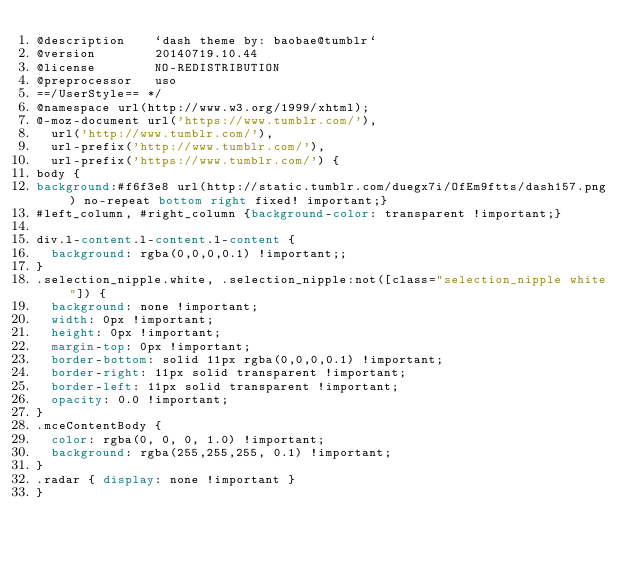<code> <loc_0><loc_0><loc_500><loc_500><_CSS_>@description    `dash theme by: baobae@tumblr`
@version        20140719.10.44
@license        NO-REDISTRIBUTION
@preprocessor   uso
==/UserStyle== */
@namespace url(http://www.w3.org/1999/xhtml);
@-moz-document url('https://www.tumblr.com/'),
  url('http://www.tumblr.com/'),
  url-prefix('http://www.tumblr.com/'),
  url-prefix('https://www.tumblr.com/') {
body {
background:#f6f3e8 url(http://static.tumblr.com/duegx7i/OfEm9ftts/dash157.png) no-repeat bottom right fixed! important;}
#left_column, #right_column {background-color: transparent !important;}

div.l-content.l-content.l-content {
  background: rgba(0,0,0,0.1) !important;;
}
.selection_nipple.white, .selection_nipple:not([class="selection_nipple white"]) {
  background: none !important;
  width: 0px !important;
  height: 0px !important;
  margin-top: 0px !important;
  border-bottom: solid 11px rgba(0,0,0,0.1) !important;
  border-right: 11px solid transparent !important;
  border-left: 11px solid transparent !important;
  opacity: 0.0 !important;
}
.mceContentBody {
  color: rgba(0, 0, 0, 1.0) !important;
  background: rgba(255,255,255, 0.1) !important;
}
.radar { display: none !important }
}
</code> 